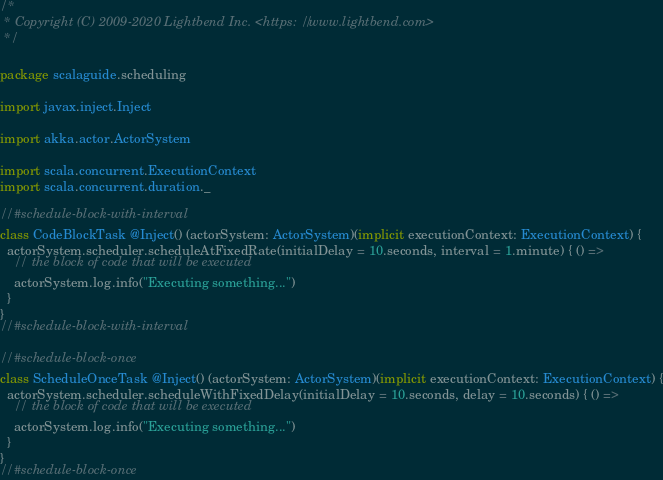<code> <loc_0><loc_0><loc_500><loc_500><_Scala_>/*
 * Copyright (C) 2009-2020 Lightbend Inc. <https://www.lightbend.com>
 */

package scalaguide.scheduling

import javax.inject.Inject

import akka.actor.ActorSystem

import scala.concurrent.ExecutionContext
import scala.concurrent.duration._

//#schedule-block-with-interval
class CodeBlockTask @Inject() (actorSystem: ActorSystem)(implicit executionContext: ExecutionContext) {
  actorSystem.scheduler.scheduleAtFixedRate(initialDelay = 10.seconds, interval = 1.minute) { () =>
    // the block of code that will be executed
    actorSystem.log.info("Executing something...")
  }
}
//#schedule-block-with-interval

//#schedule-block-once
class ScheduleOnceTask @Inject() (actorSystem: ActorSystem)(implicit executionContext: ExecutionContext) {
  actorSystem.scheduler.scheduleWithFixedDelay(initialDelay = 10.seconds, delay = 10.seconds) { () =>
    // the block of code that will be executed
    actorSystem.log.info("Executing something...")
  }
}
//#schedule-block-once
</code> 